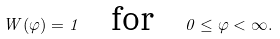<formula> <loc_0><loc_0><loc_500><loc_500>W ( \varphi ) = 1 \quad \text {for} \quad 0 \leq \varphi < \infty .</formula> 